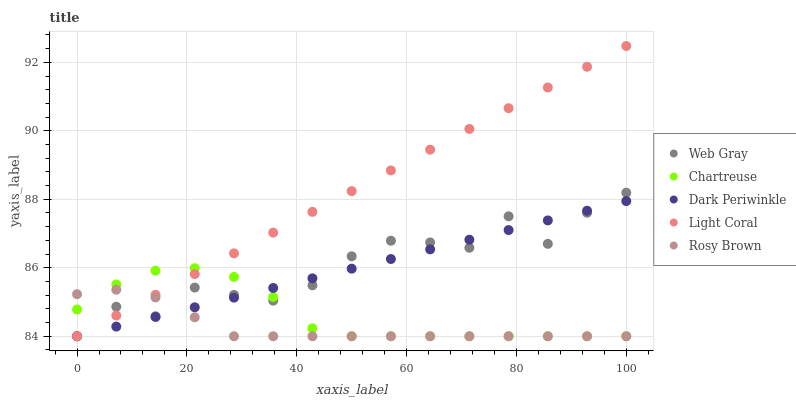Does Rosy Brown have the minimum area under the curve?
Answer yes or no. Yes. Does Light Coral have the maximum area under the curve?
Answer yes or no. Yes. Does Chartreuse have the minimum area under the curve?
Answer yes or no. No. Does Chartreuse have the maximum area under the curve?
Answer yes or no. No. Is Dark Periwinkle the smoothest?
Answer yes or no. Yes. Is Web Gray the roughest?
Answer yes or no. Yes. Is Chartreuse the smoothest?
Answer yes or no. No. Is Chartreuse the roughest?
Answer yes or no. No. Does Light Coral have the lowest value?
Answer yes or no. Yes. Does Light Coral have the highest value?
Answer yes or no. Yes. Does Chartreuse have the highest value?
Answer yes or no. No. Does Light Coral intersect Rosy Brown?
Answer yes or no. Yes. Is Light Coral less than Rosy Brown?
Answer yes or no. No. Is Light Coral greater than Rosy Brown?
Answer yes or no. No. 